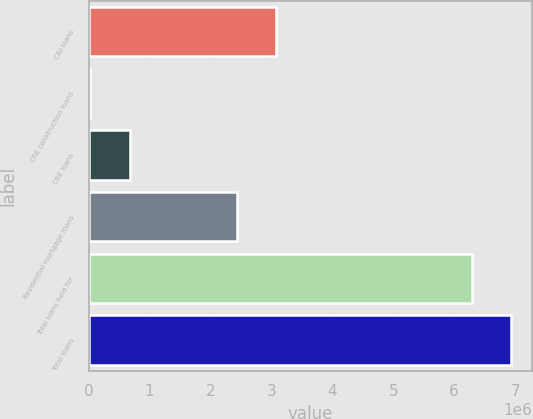Convert chart to OTSL. <chart><loc_0><loc_0><loc_500><loc_500><bar_chart><fcel>C&I loans<fcel>CRE construction loans<fcel>CRE loans<fcel>Residential mortgage loans<fcel>Total loans held for<fcel>Total loans<nl><fcel>3.08003e+06<fcel>29557<fcel>675356<fcel>2.43423e+06<fcel>6.28458e+06<fcel>6.93038e+06<nl></chart> 